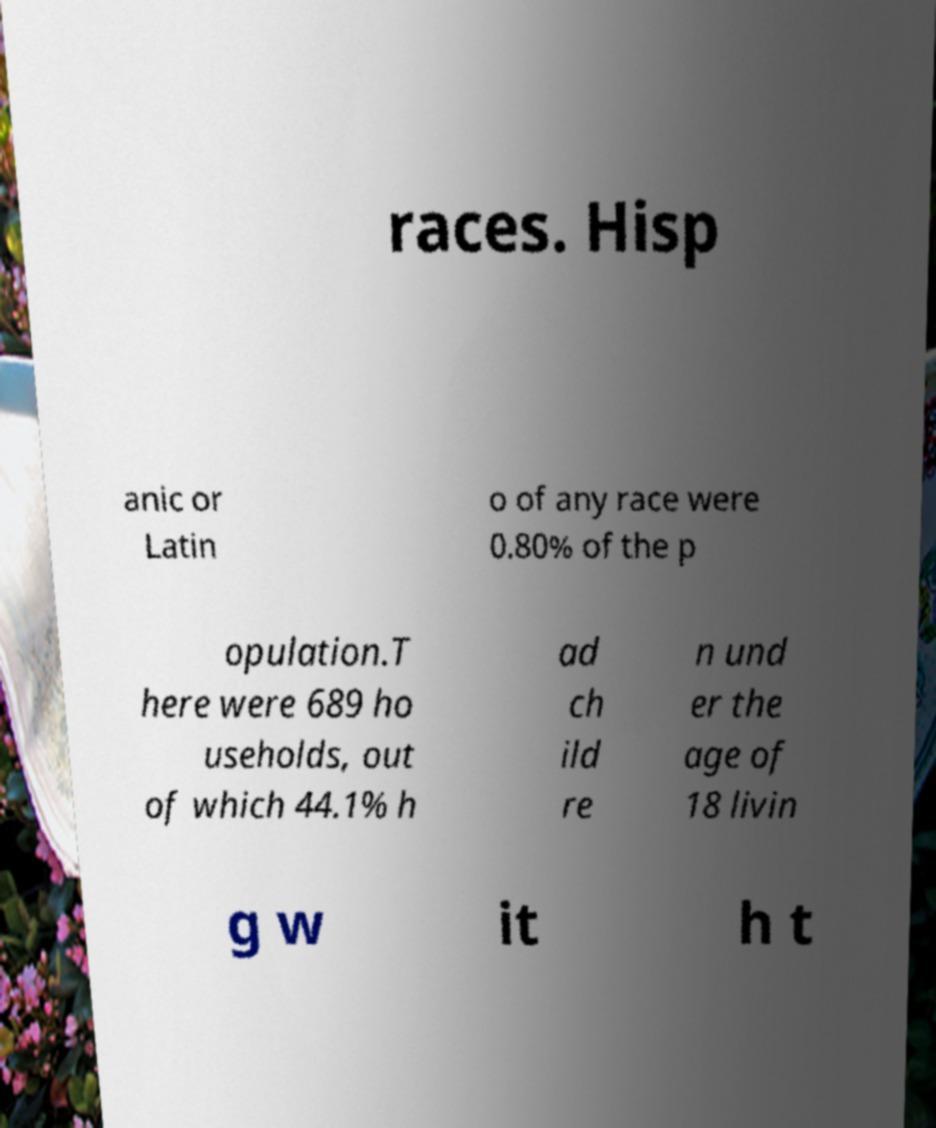For documentation purposes, I need the text within this image transcribed. Could you provide that? races. Hisp anic or Latin o of any race were 0.80% of the p opulation.T here were 689 ho useholds, out of which 44.1% h ad ch ild re n und er the age of 18 livin g w it h t 